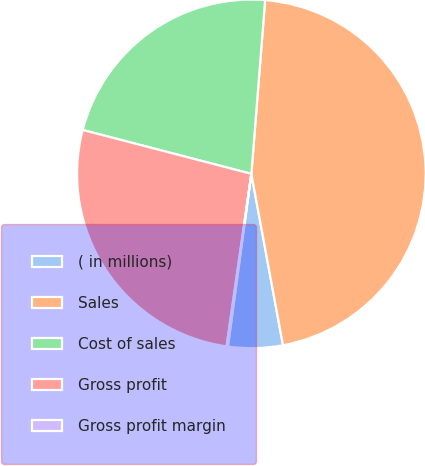<chart> <loc_0><loc_0><loc_500><loc_500><pie_chart><fcel>( in millions)<fcel>Sales<fcel>Cost of sales<fcel>Gross profit<fcel>Gross profit margin<nl><fcel>5.05%<fcel>45.84%<fcel>22.21%<fcel>26.78%<fcel>0.13%<nl></chart> 